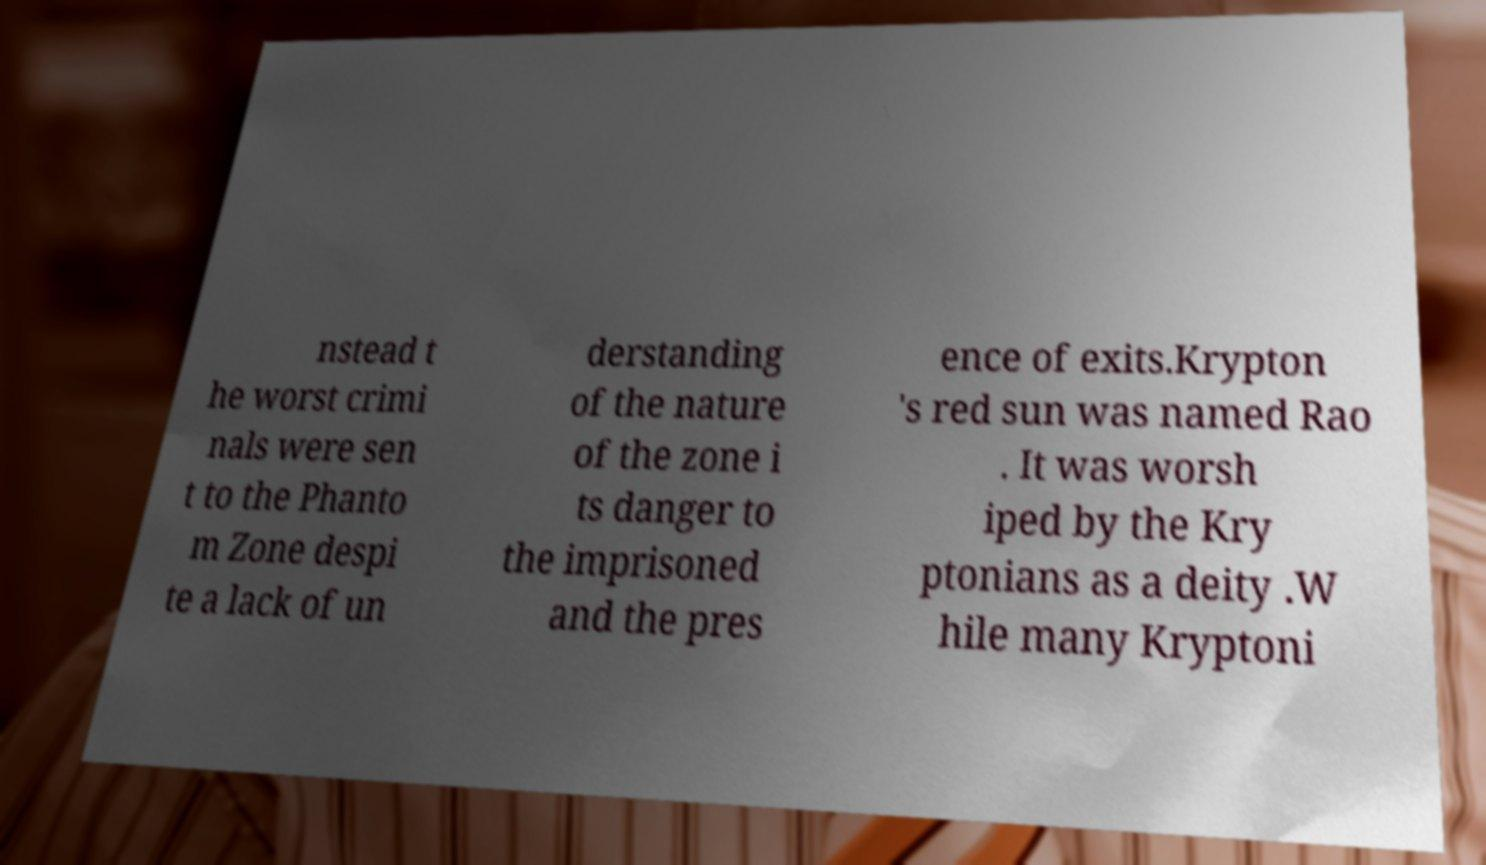What messages or text are displayed in this image? I need them in a readable, typed format. nstead t he worst crimi nals were sen t to the Phanto m Zone despi te a lack of un derstanding of the nature of the zone i ts danger to the imprisoned and the pres ence of exits.Krypton 's red sun was named Rao . It was worsh iped by the Kry ptonians as a deity .W hile many Kryptoni 